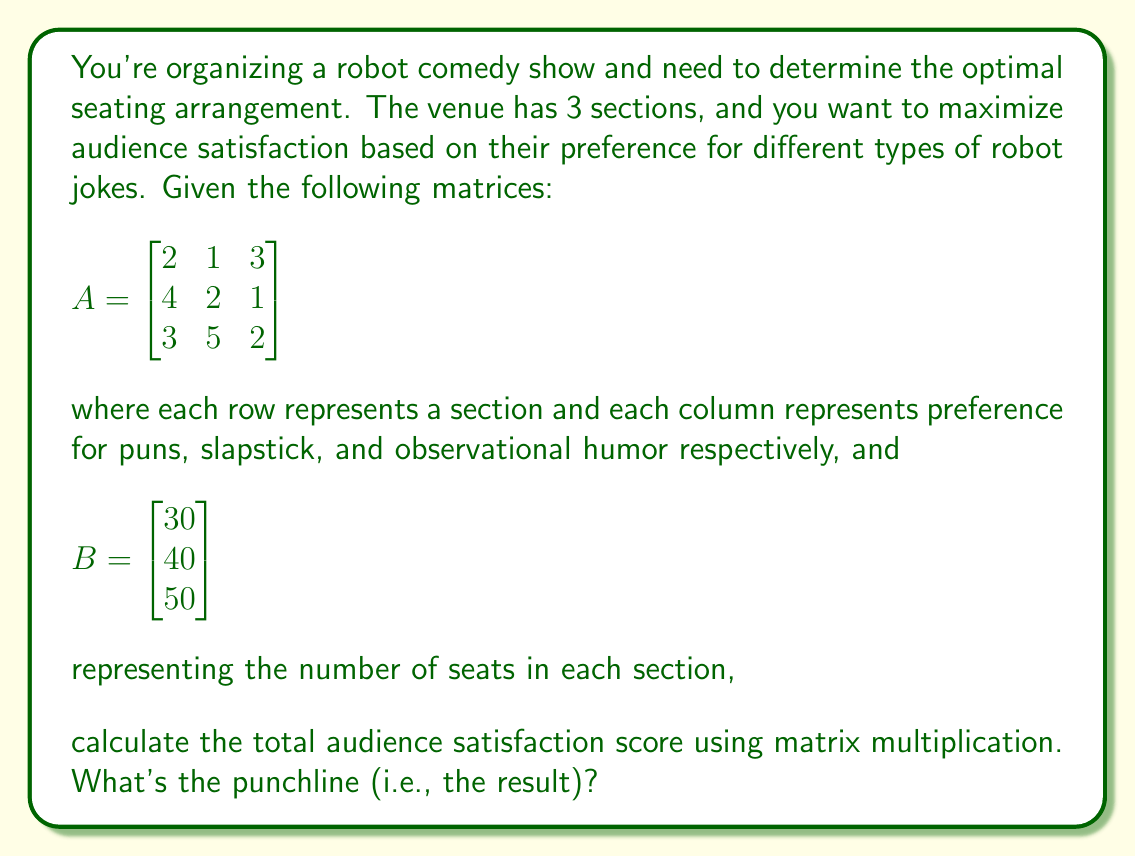Solve this math problem. To solve this problem, we need to perform matrix multiplication between matrix $A$ and matrix $B$. This will give us a 3x1 matrix representing the total satisfaction score for each type of humor.

Step 1: Set up the matrix multiplication
$$C = A \times B = \begin{bmatrix} 2 & 1 & 3 \\ 4 & 2 & 1 \\ 3 & 5 & 2 \end{bmatrix} \times \begin{bmatrix} 30 \\ 40 \\ 50 \end{bmatrix}$$

Step 2: Perform the multiplication
$C_1 = (2 \times 30) + (1 \times 40) + (3 \times 50) = 60 + 40 + 150 = 250$
$C_2 = (4 \times 30) + (2 \times 40) + (1 \times 50) = 120 + 80 + 50 = 250$
$C_3 = (3 \times 30) + (5 \times 40) + (2 \times 50) = 90 + 200 + 100 = 390$

Step 3: Write the result as a matrix
$$C = \begin{bmatrix} 250 \\ 250 \\ 390 \end{bmatrix}$$

Step 4: Sum up the elements to get the total satisfaction score
Total satisfaction score = 250 + 250 + 390 = 890
Answer: 890 